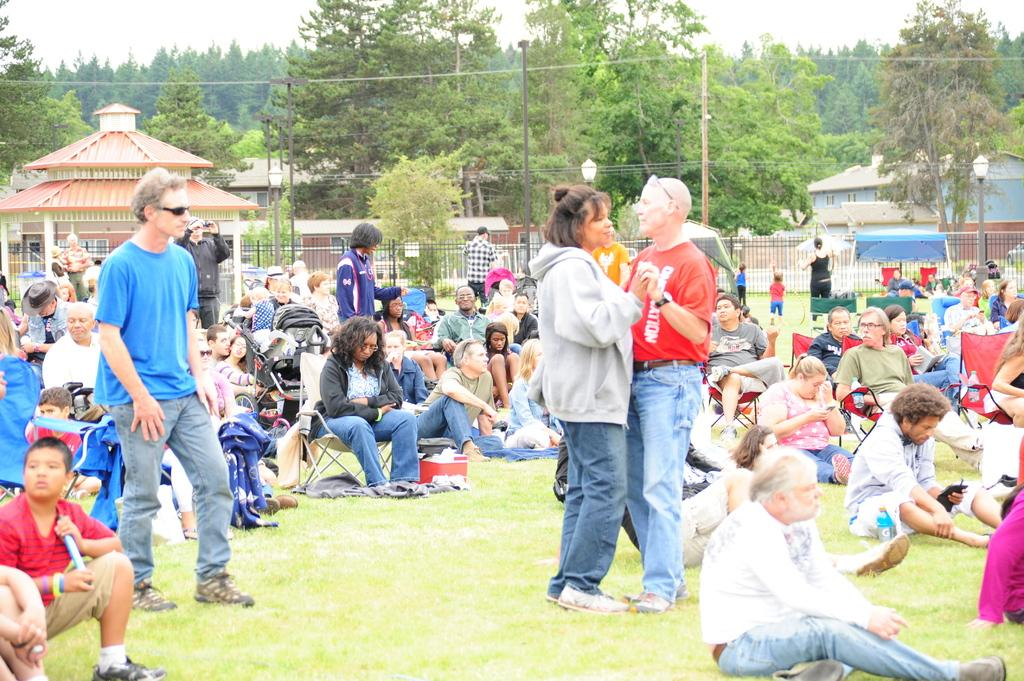What are the people in the image doing? There are people sitting on the grass and chairs, as well as people standing in the image. What can be seen in the background of the image? There are houses, trees, poles with wires, and the sky visible in the background. What type of comb is being used by the person sitting on the grass? There is no comb present in the image. What is the cart used for in the image? There is no cart present in the image. 